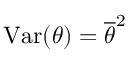<formula> <loc_0><loc_0><loc_500><loc_500>V a r ( \theta ) = \overline { \theta } ^ { 2 }</formula> 